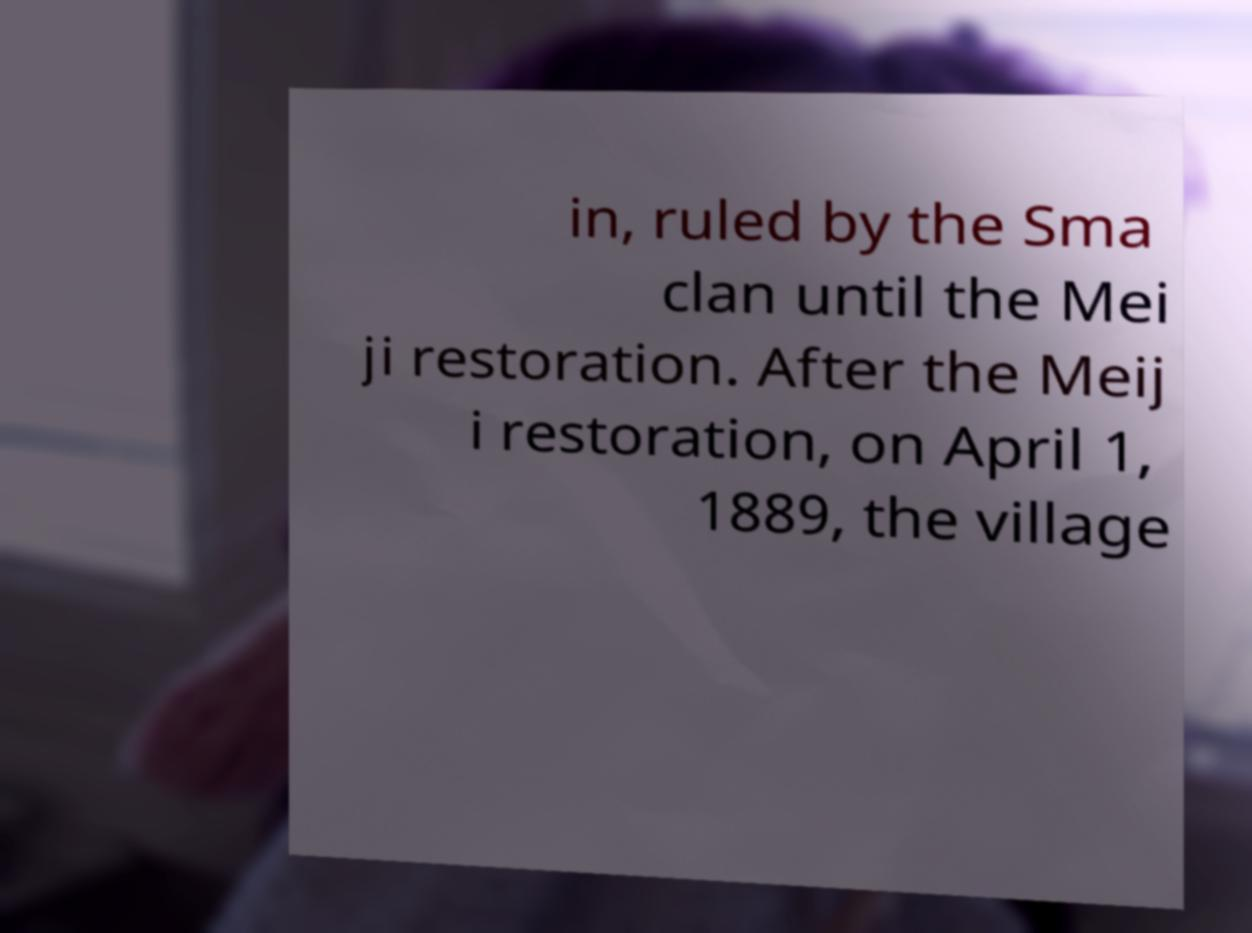For documentation purposes, I need the text within this image transcribed. Could you provide that? in, ruled by the Sma clan until the Mei ji restoration. After the Meij i restoration, on April 1, 1889, the village 